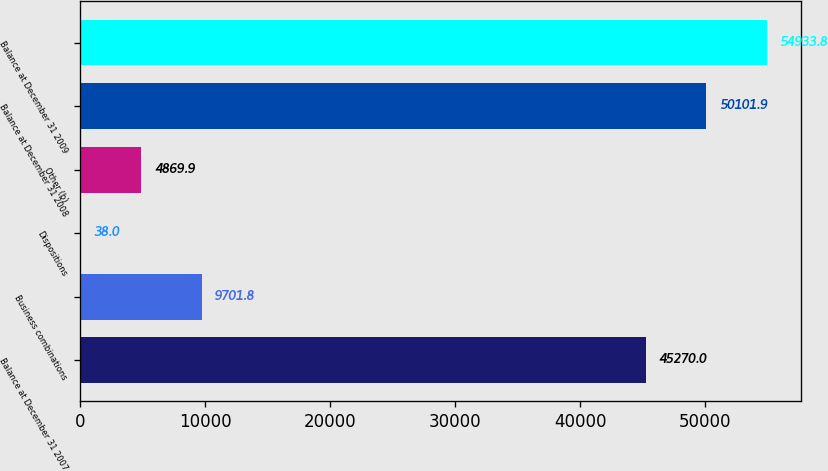<chart> <loc_0><loc_0><loc_500><loc_500><bar_chart><fcel>Balance at December 31 2007<fcel>Business combinations<fcel>Dispositions<fcel>Other (b)<fcel>Balance at December 31 2008<fcel>Balance at December 31 2009<nl><fcel>45270<fcel>9701.8<fcel>38<fcel>4869.9<fcel>50101.9<fcel>54933.8<nl></chart> 